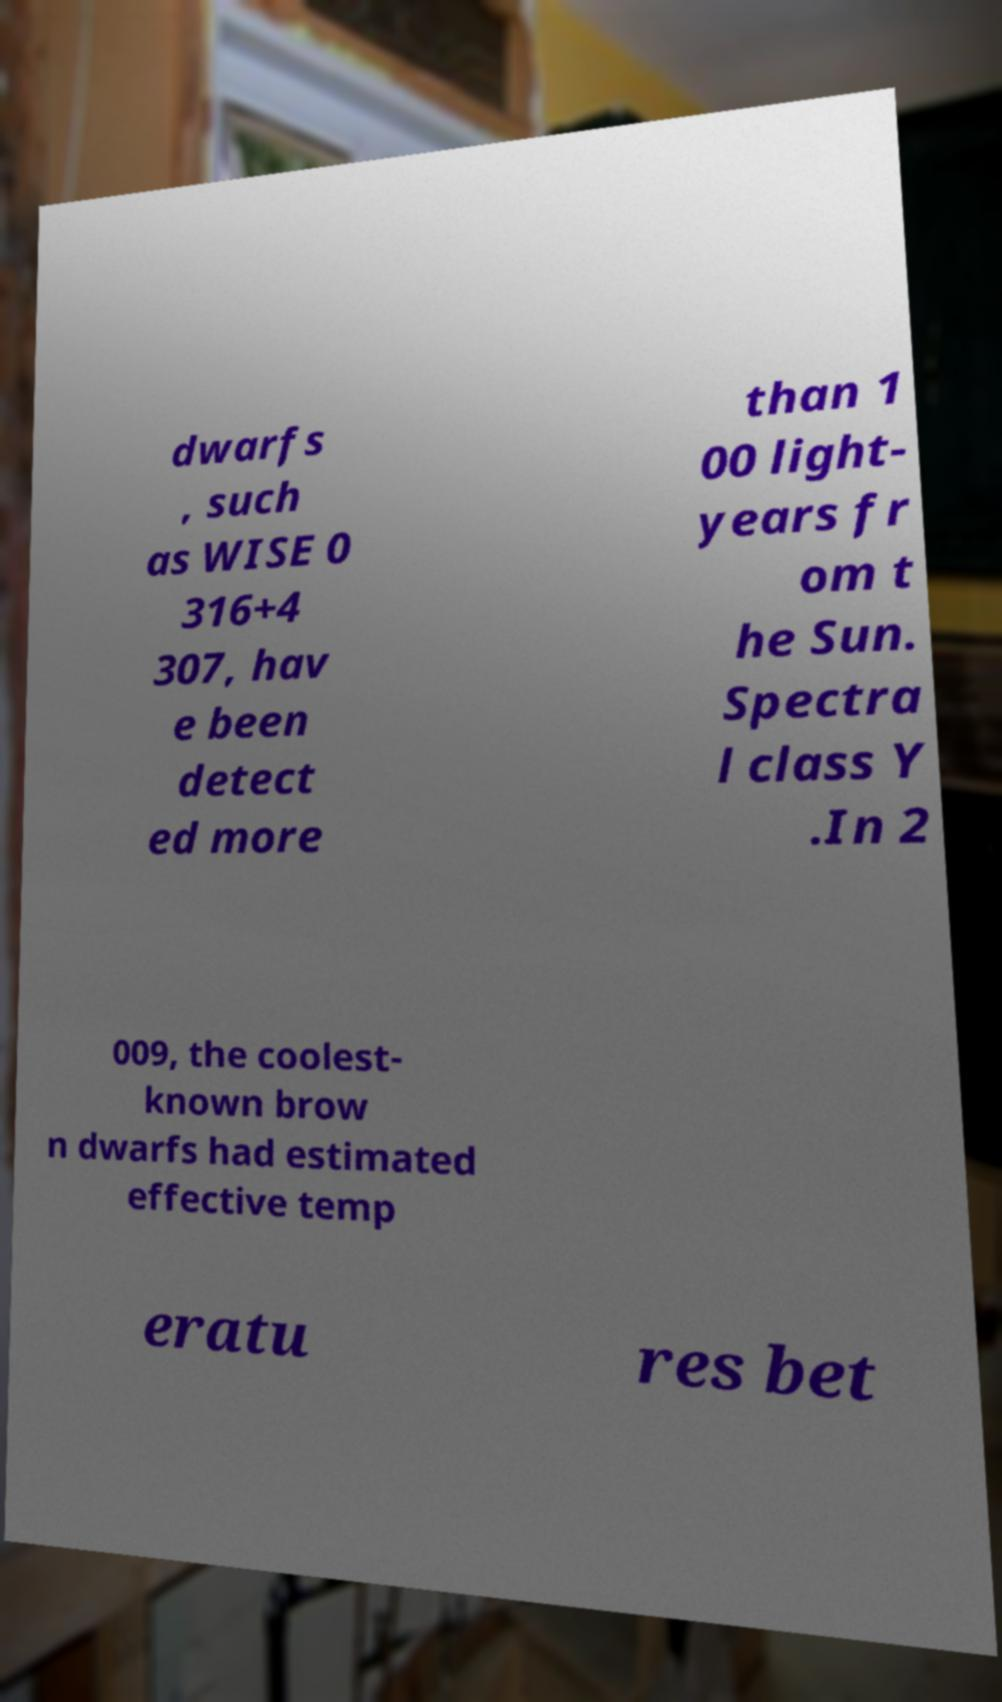Could you extract and type out the text from this image? dwarfs , such as WISE 0 316+4 307, hav e been detect ed more than 1 00 light- years fr om t he Sun. Spectra l class Y .In 2 009, the coolest- known brow n dwarfs had estimated effective temp eratu res bet 